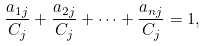<formula> <loc_0><loc_0><loc_500><loc_500>\frac { a _ { 1 j } } { C _ { j } } + \frac { a _ { 2 j } } { C _ { j } } + \dots + \frac { a _ { n j } } { C _ { j } } = 1 ,</formula> 